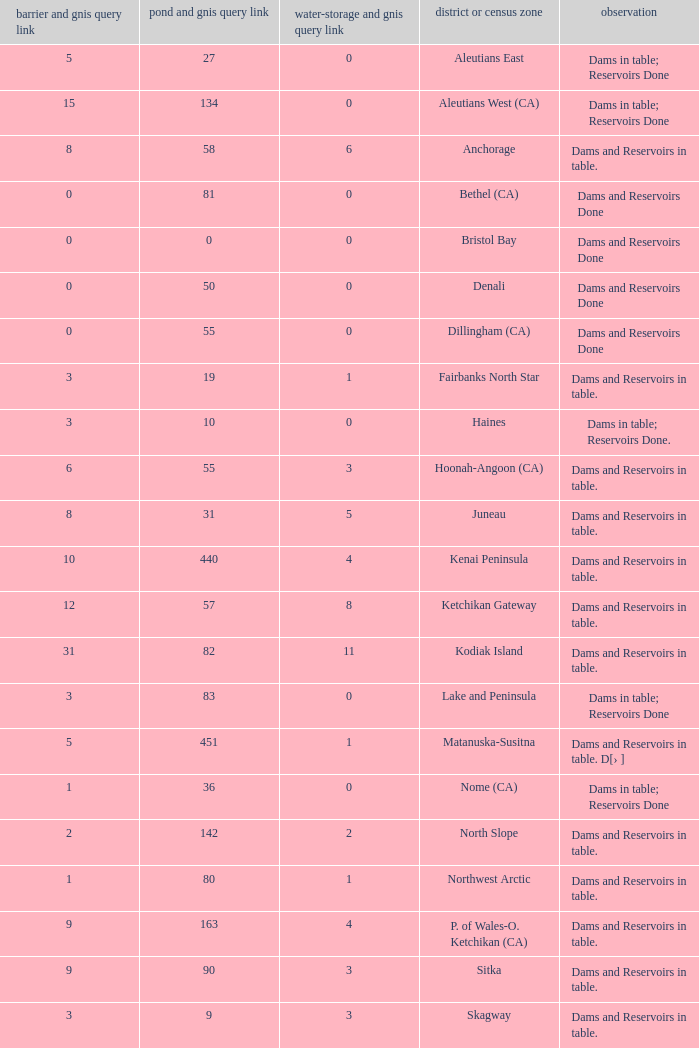Name the minimum number of reservoir for gnis query link where numbers lake gnis query link being 60 5.0. 